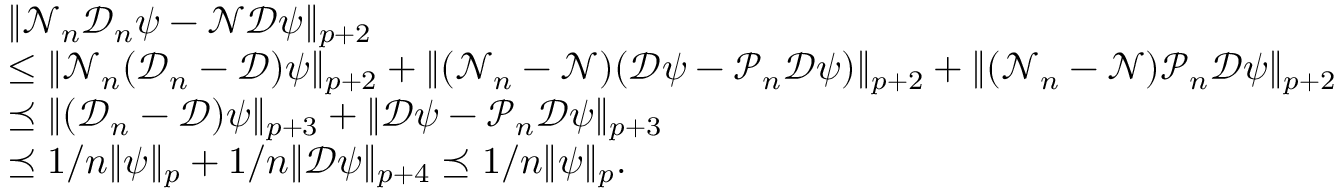<formula> <loc_0><loc_0><loc_500><loc_500>\begin{array} { r l } & { \| \mathcal { N } _ { n } \mathcal { D } _ { n } \psi - \mathcal { N } \mathcal { D } \psi \| _ { p + 2 } } \\ & { \leq \| \mathcal { N } _ { n } ( \mathcal { D } _ { n } - \mathcal { D } ) \psi \| _ { p + 2 } + \| ( \mathcal { N } _ { n } - \mathcal { N } ) ( \mathcal { D } \psi - \mathcal { P } _ { n } \mathcal { D } \psi ) \| _ { p + 2 } + \| ( \mathcal { N } _ { n } - \mathcal { N } ) \mathcal { P } _ { n } \mathcal { D } \psi \| _ { p + 2 } } \\ & { \preceq \| ( \mathcal { D } _ { n } - \mathcal { D } ) \psi \| _ { p + 3 } + \| \mathcal { D } \psi - \mathcal { P } _ { n } \mathcal { D } \psi \| _ { p + 3 } } \\ & { \preceq 1 / n \| \psi \| _ { p } + 1 / n \| \mathcal { D } \psi \| _ { p + 4 } \preceq 1 / n \| \psi \| _ { p } . } \end{array}</formula> 